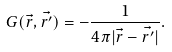Convert formula to latex. <formula><loc_0><loc_0><loc_500><loc_500>G ( \vec { r } , \vec { r ^ { \prime } } ) = - \frac { 1 } { 4 \pi | \vec { r } - \vec { r ^ { \prime } } | } .</formula> 